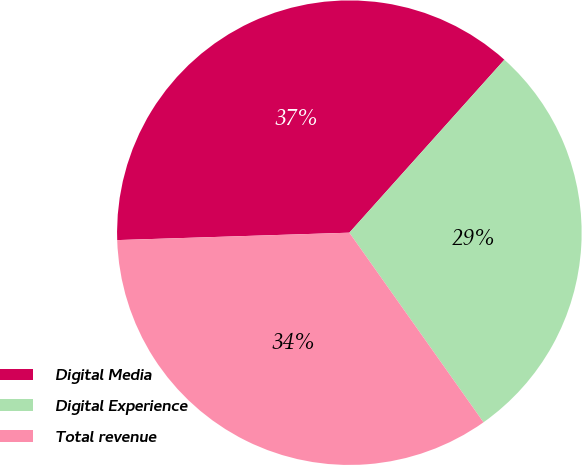Convert chart to OTSL. <chart><loc_0><loc_0><loc_500><loc_500><pie_chart><fcel>Digital Media<fcel>Digital Experience<fcel>Total revenue<nl><fcel>37.14%<fcel>28.57%<fcel>34.29%<nl></chart> 